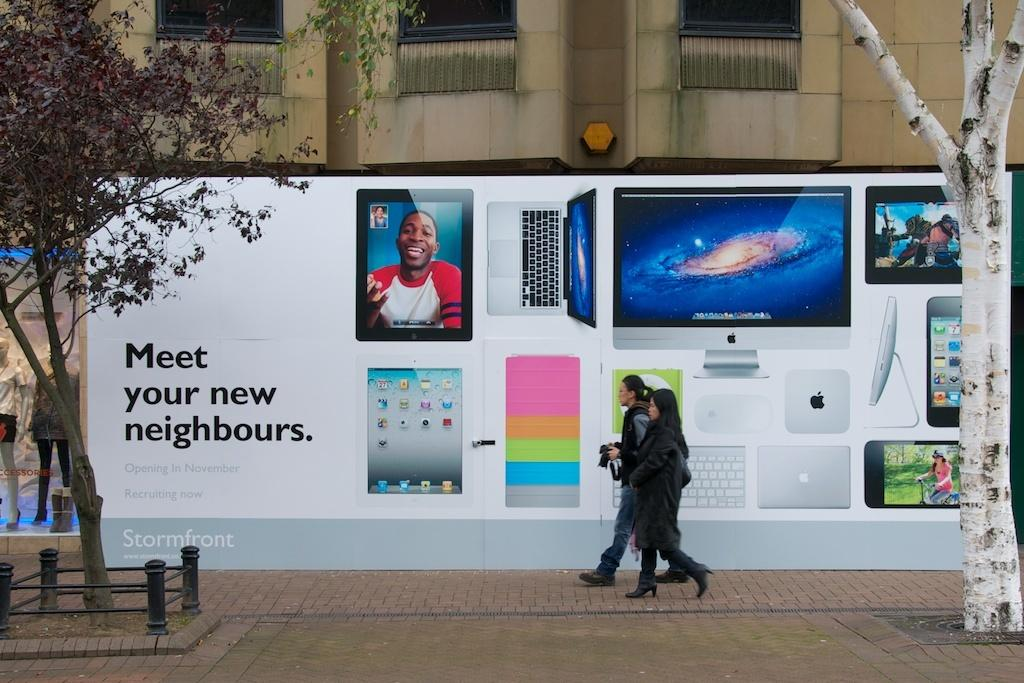<image>
Provide a brief description of the given image. A big street-level billboard says that we should meet our new neighbours. 